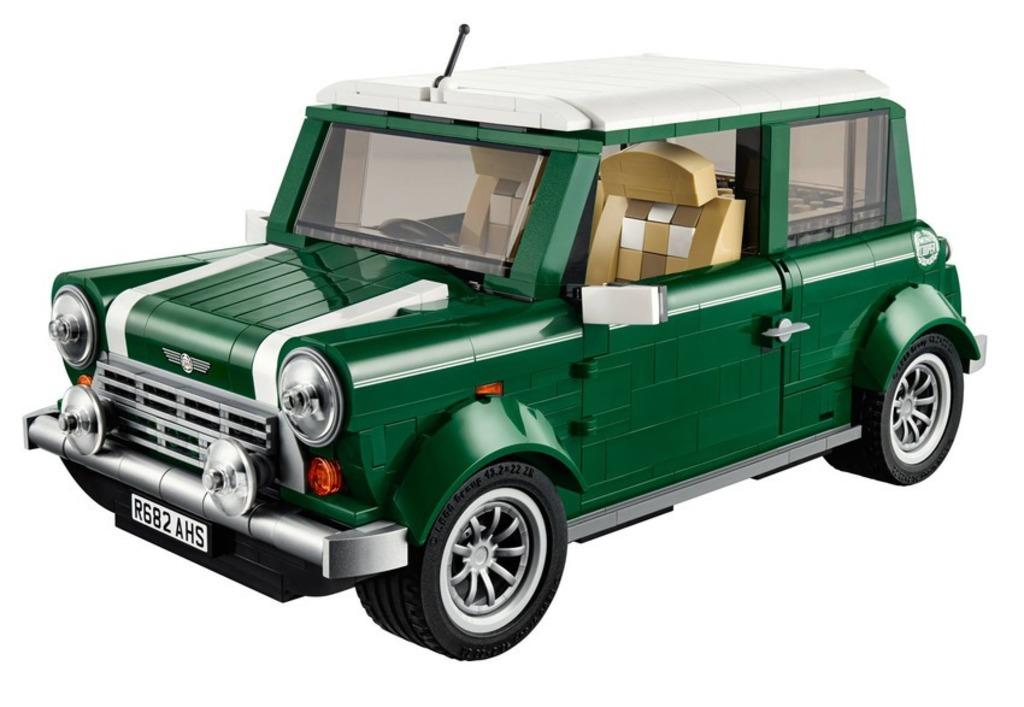What is the main subject of the image? The main subject of the image is a car. What is the color of the car? The car is dark green in color. Where is the car located in the image? The car is on a white surface. Can you see an owl sitting on the car in the image? No, there is no owl present in the image. 